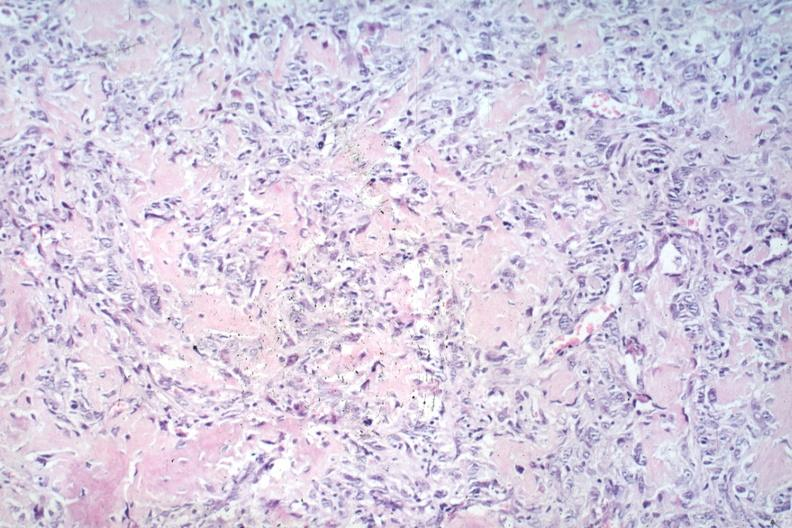s joints present?
Answer the question using a single word or phrase. Yes 